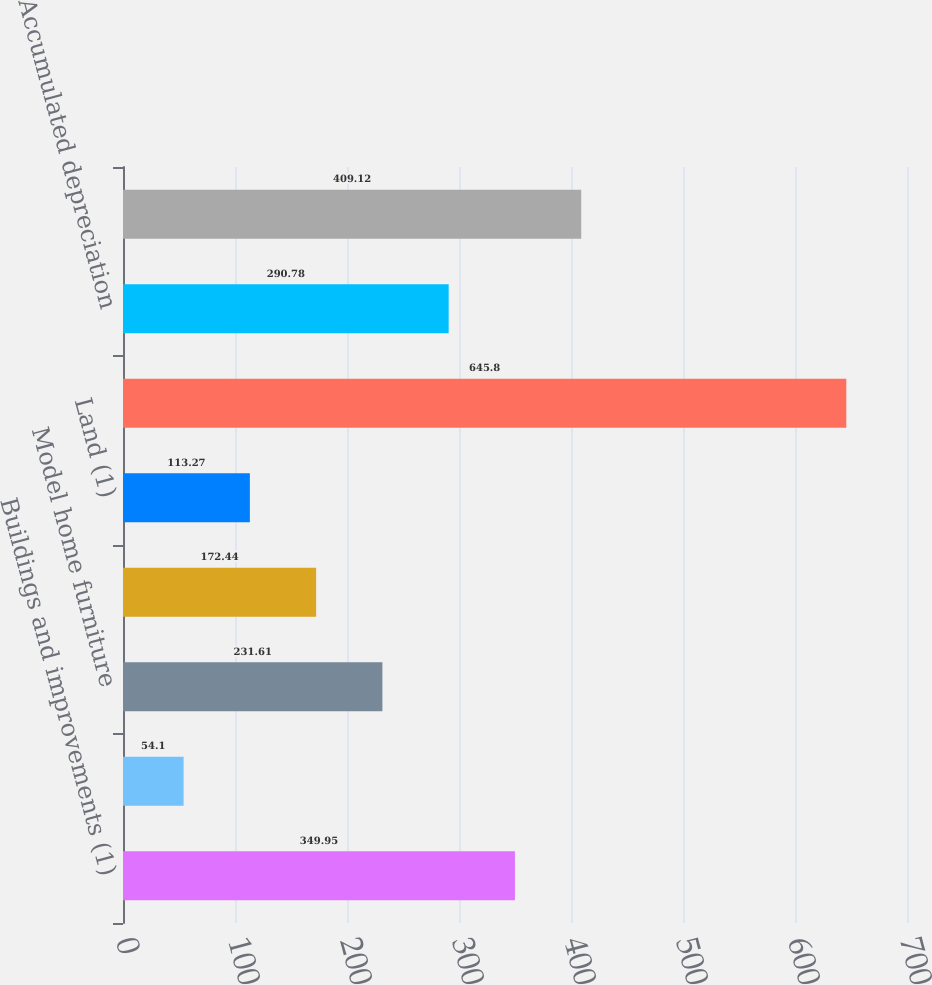Convert chart. <chart><loc_0><loc_0><loc_500><loc_500><bar_chart><fcel>Buildings and improvements (1)<fcel>Multi-family rental properties<fcel>Model home furniture<fcel>Office furniture and equipment<fcel>Land (1)<fcel>Total property and equipment<fcel>Accumulated depreciation<fcel>Property and equipment net<nl><fcel>349.95<fcel>54.1<fcel>231.61<fcel>172.44<fcel>113.27<fcel>645.8<fcel>290.78<fcel>409.12<nl></chart> 